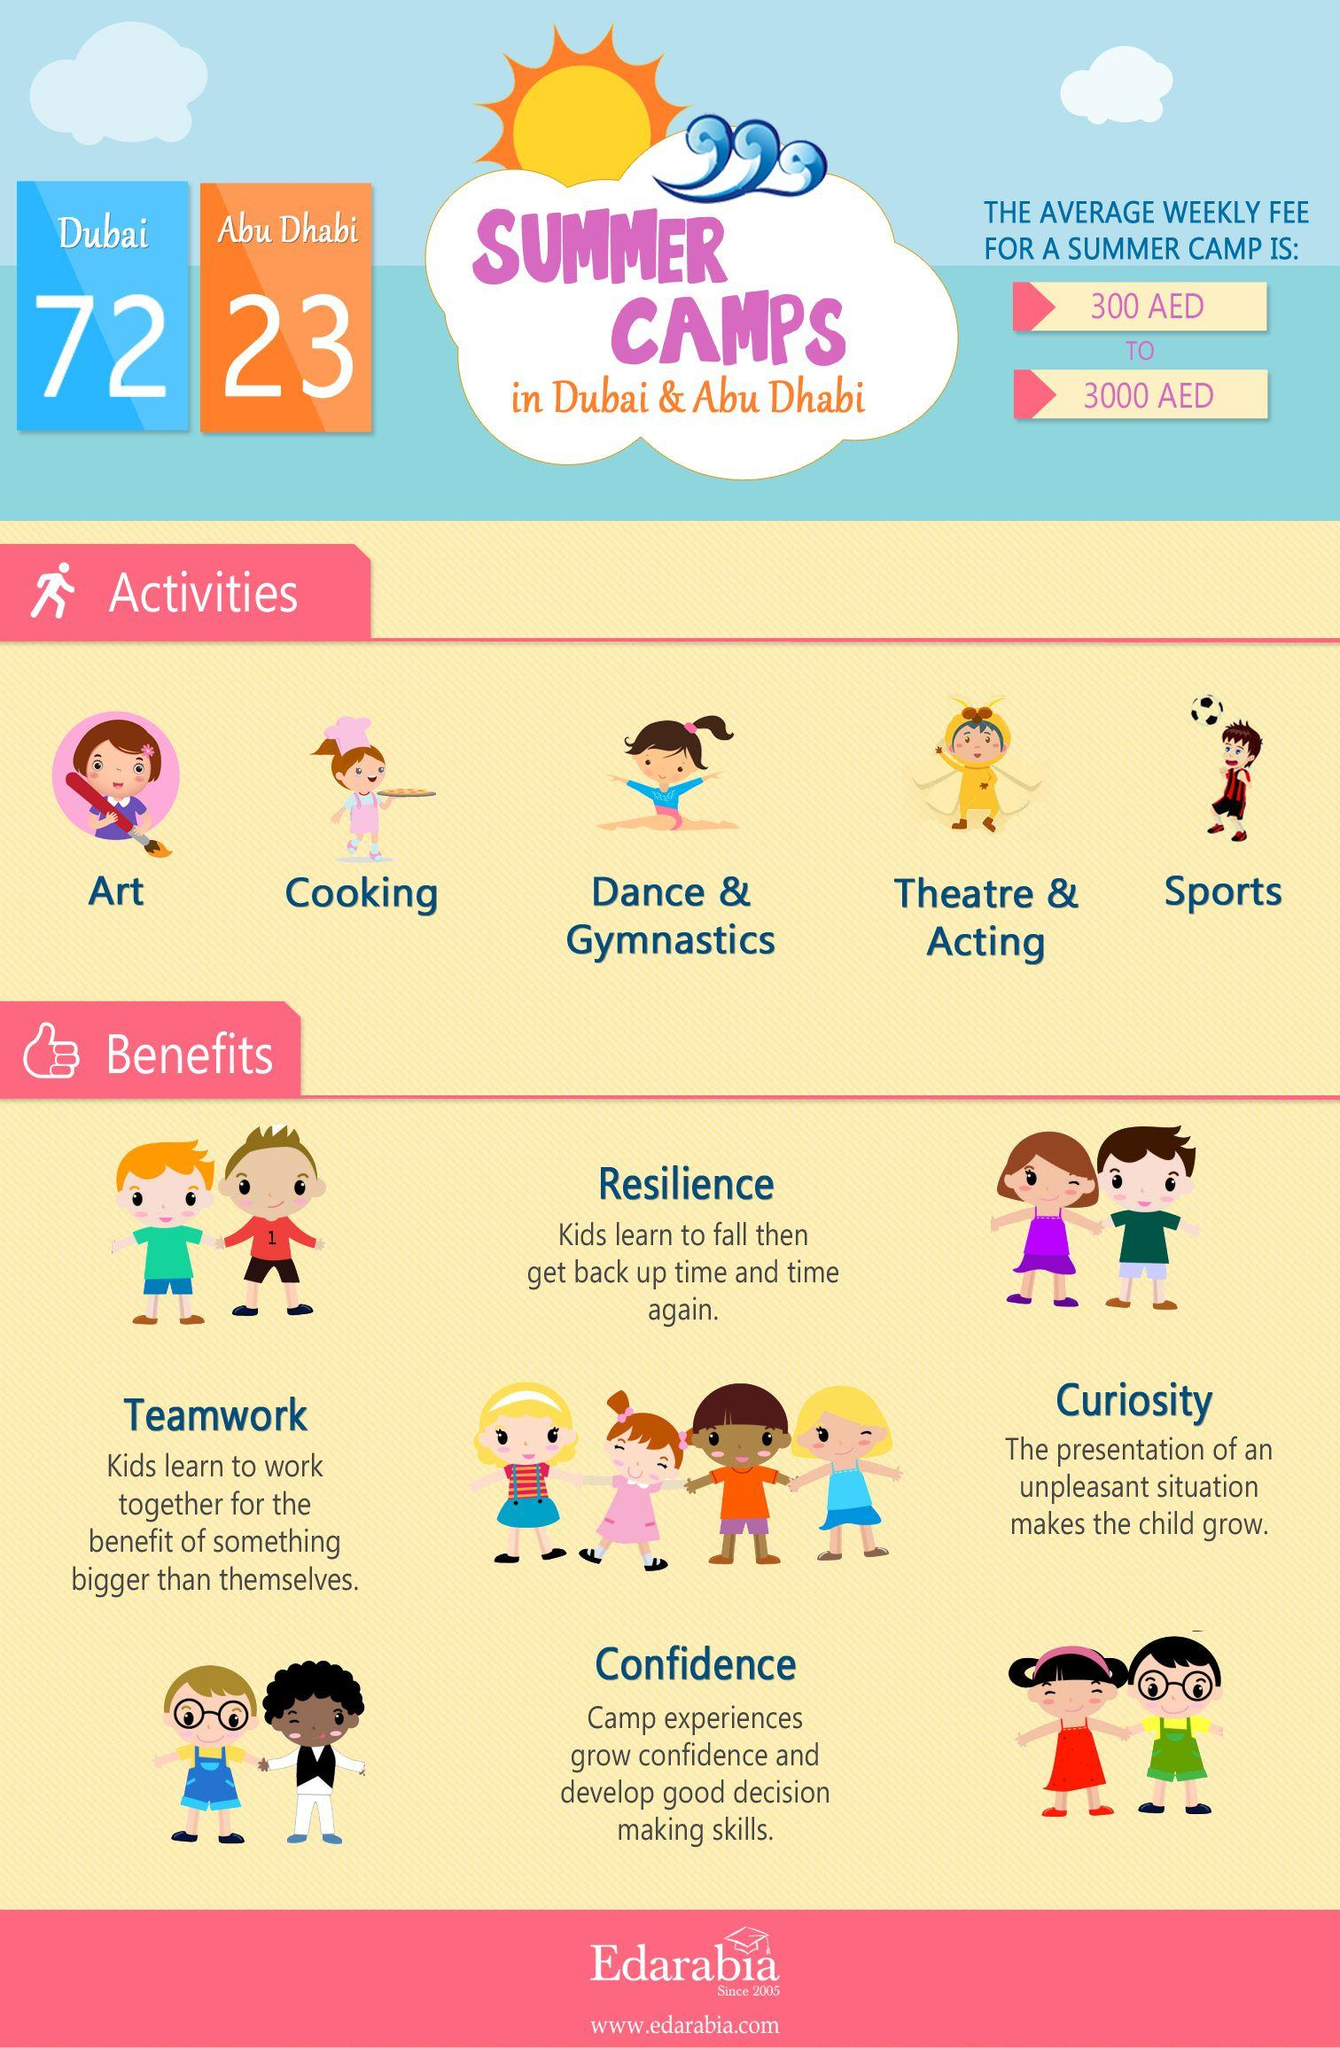Mention a couple of crucial points in this snapshot. Summer camps have 5 activities in total. There are 23 summer camps in Abu Dhabi. There are 72 summer camps in Dubai. 